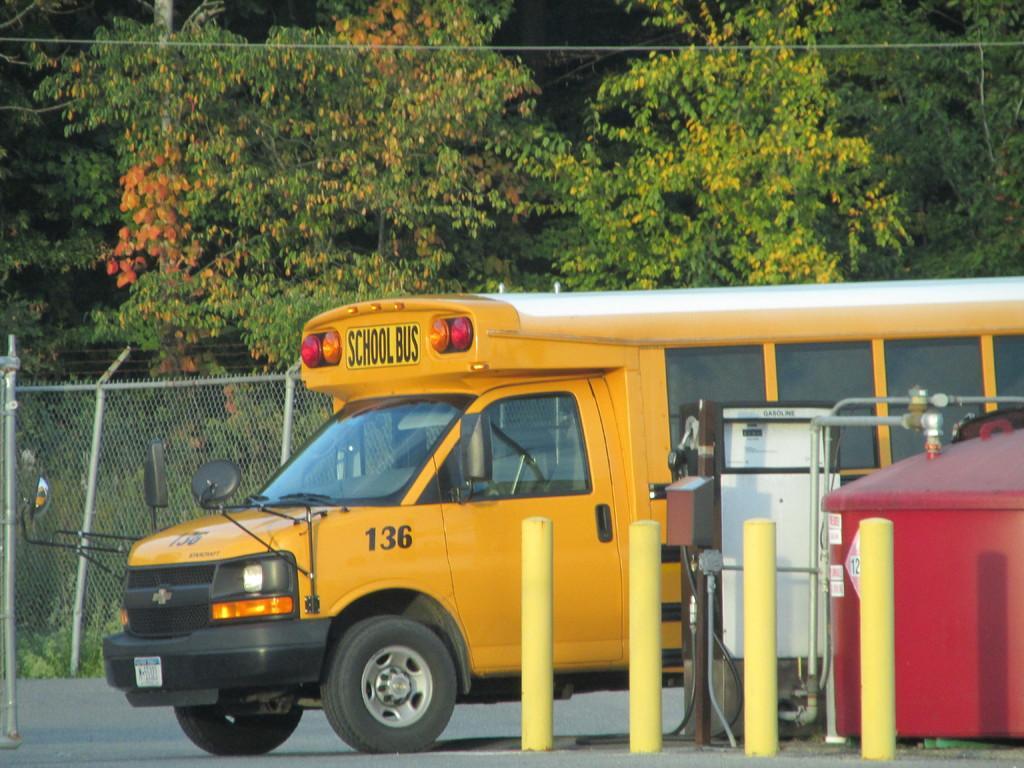In one or two sentences, can you explain what this image depicts? In the middle of the picture, we see a yellow bus is moving on the road. Beside that, we see small poles. On the right side, we see an object in red color. Beside that, we see a white color meter box. Behind the bus, we see a fence. There are trees in the background. At the bottom of the picture, we see the road. 